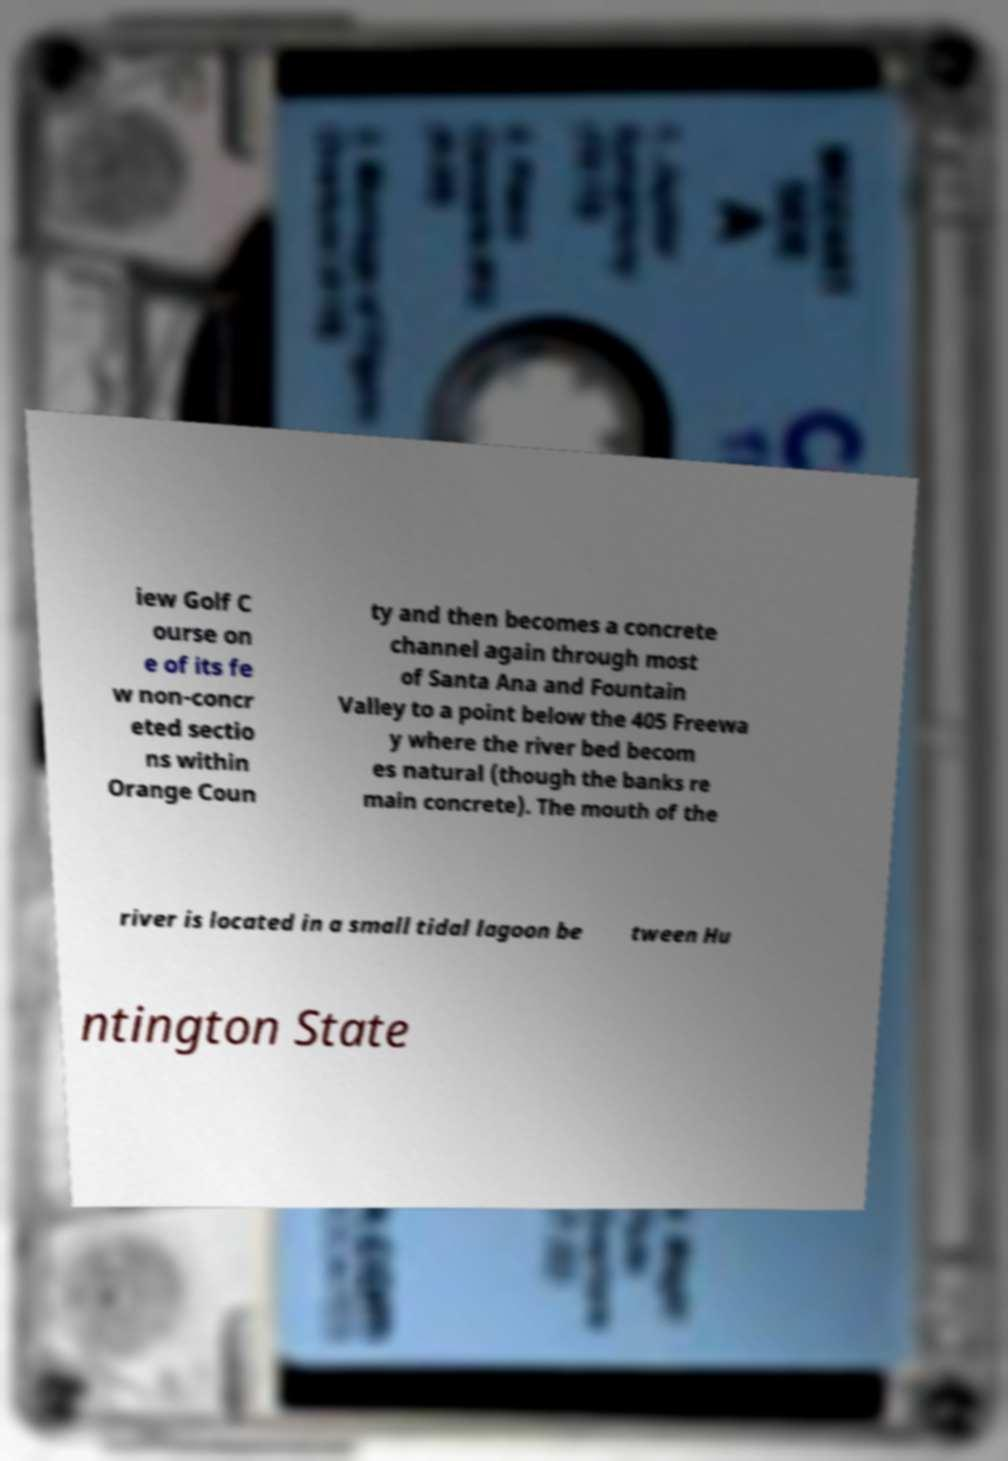Can you read and provide the text displayed in the image?This photo seems to have some interesting text. Can you extract and type it out for me? iew Golf C ourse on e of its fe w non-concr eted sectio ns within Orange Coun ty and then becomes a concrete channel again through most of Santa Ana and Fountain Valley to a point below the 405 Freewa y where the river bed becom es natural (though the banks re main concrete). The mouth of the river is located in a small tidal lagoon be tween Hu ntington State 